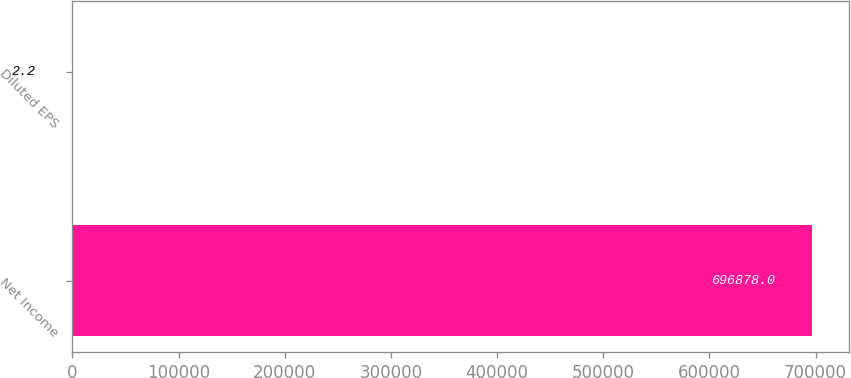<chart> <loc_0><loc_0><loc_500><loc_500><bar_chart><fcel>Net Income<fcel>Diluted EPS<nl><fcel>696878<fcel>2.2<nl></chart> 